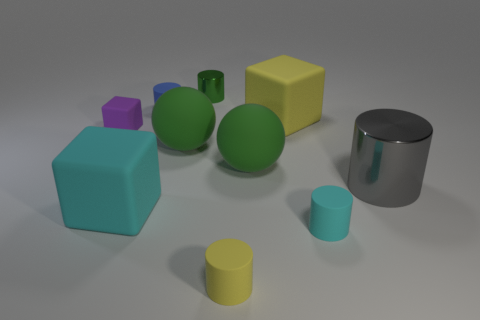Subtract all blue cylinders. How many cylinders are left? 4 Subtract all cyan cylinders. How many cylinders are left? 4 Subtract all purple cylinders. Subtract all yellow balls. How many cylinders are left? 5 Subtract all blocks. How many objects are left? 7 Add 9 small purple objects. How many small purple objects exist? 10 Subtract 0 yellow spheres. How many objects are left? 10 Subtract all green balls. Subtract all tiny green cylinders. How many objects are left? 7 Add 6 large cyan matte blocks. How many large cyan matte blocks are left? 7 